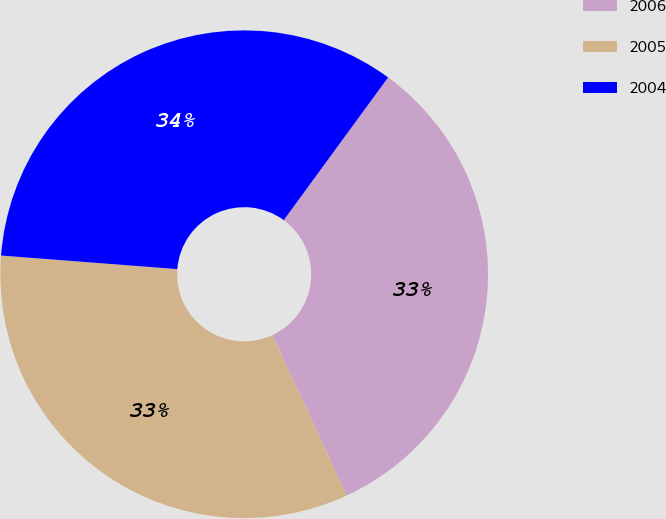Convert chart. <chart><loc_0><loc_0><loc_500><loc_500><pie_chart><fcel>2006<fcel>2005<fcel>2004<nl><fcel>33.05%<fcel>33.13%<fcel>33.83%<nl></chart> 